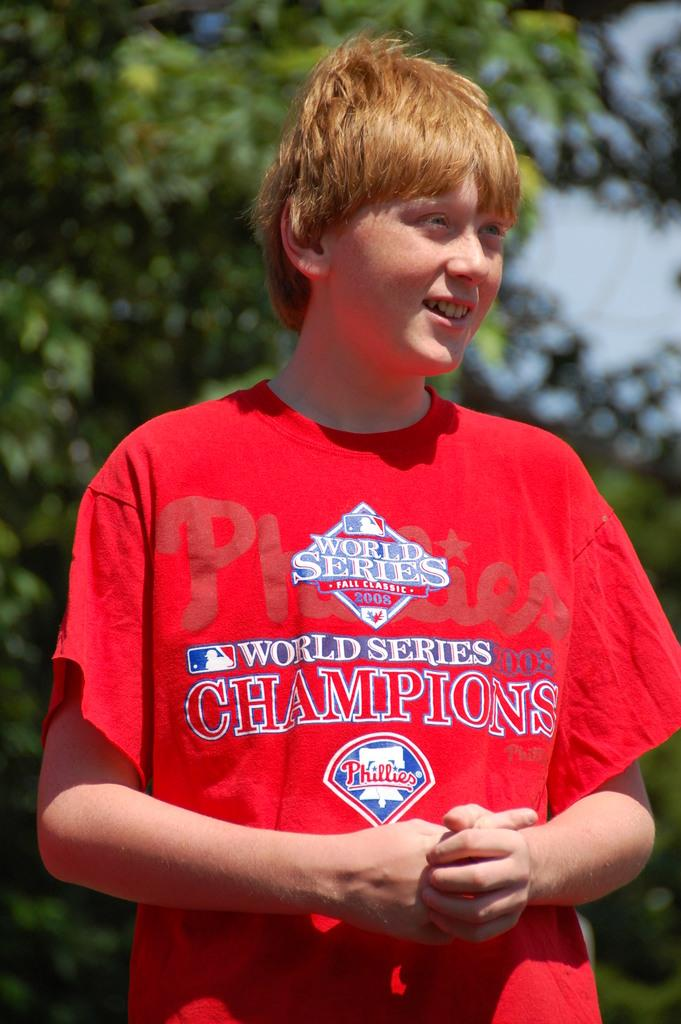What is the main subject of the image? The main subject of the image is a boy. What is the boy wearing in the image? The boy is wearing a red t-shirt in the image. What expression does the boy have in the image? The boy is smiling in the image. What can be seen in the background of the image? There are trees in the background of the image. What type of statement is the bear making in the image? There is no bear present in the image, so it is not possible to answer that question. 